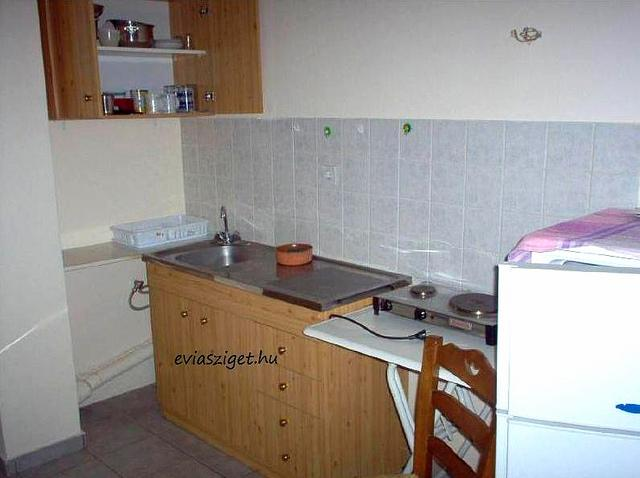What country is this? hungary 